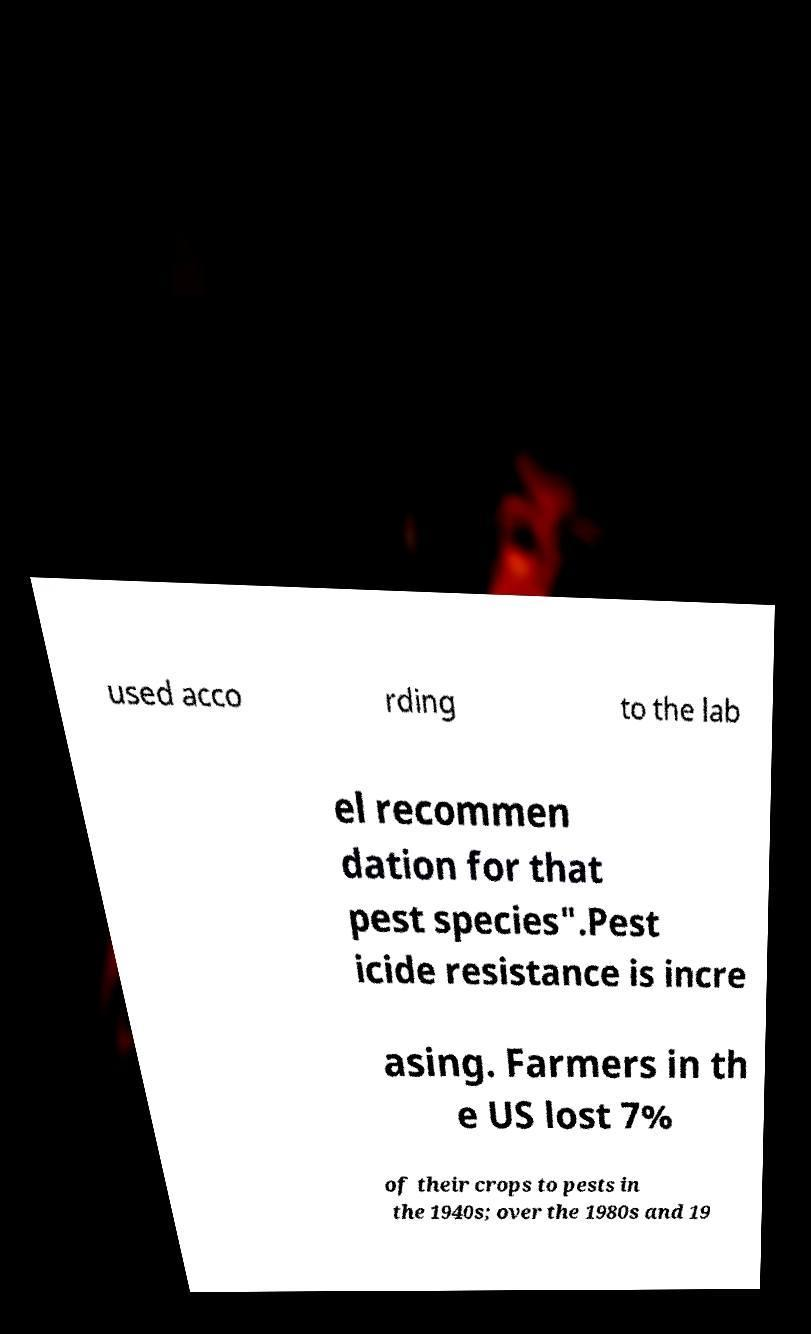Can you accurately transcribe the text from the provided image for me? used acco rding to the lab el recommen dation for that pest species".Pest icide resistance is incre asing. Farmers in th e US lost 7% of their crops to pests in the 1940s; over the 1980s and 19 